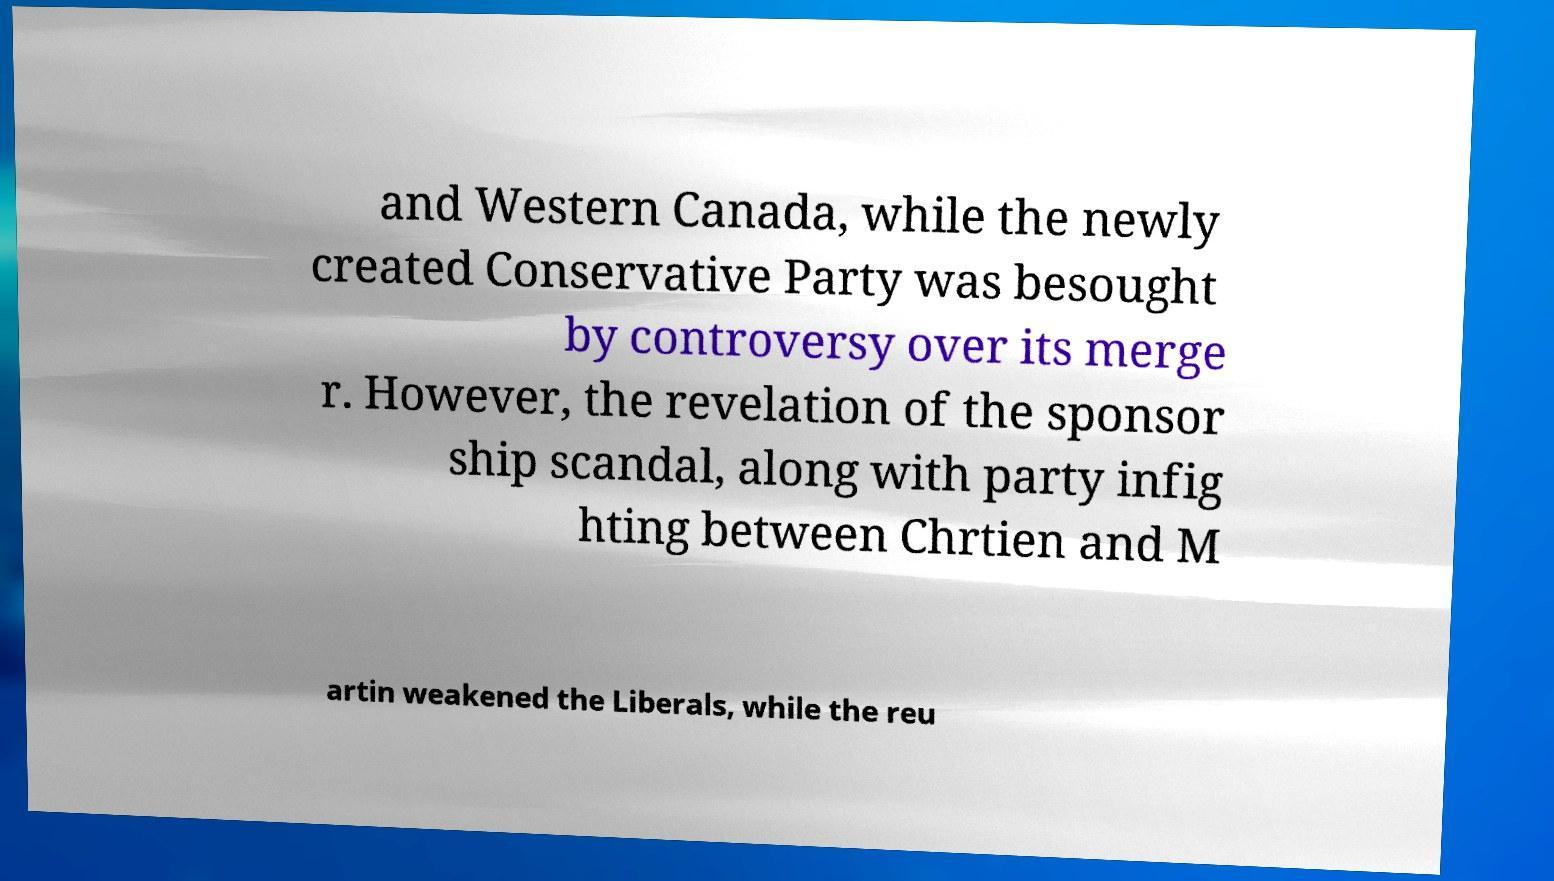What messages or text are displayed in this image? I need them in a readable, typed format. and Western Canada, while the newly created Conservative Party was besought by controversy over its merge r. However, the revelation of the sponsor ship scandal, along with party infig hting between Chrtien and M artin weakened the Liberals, while the reu 